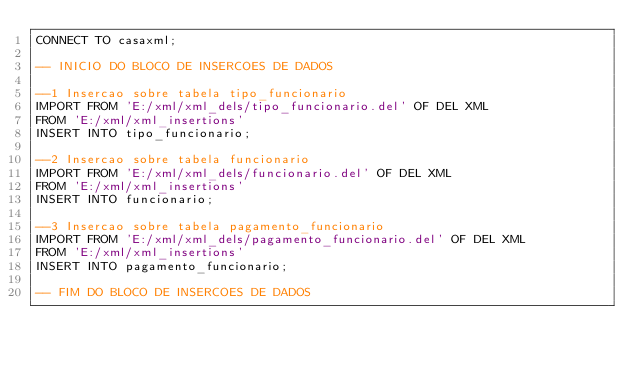<code> <loc_0><loc_0><loc_500><loc_500><_SQL_>CONNECT TO casaxml;

-- INICIO DO BLOCO DE INSERCOES DE DADOS

--1 Insercao sobre tabela tipo_funcionario
IMPORT FROM 'E:/xml/xml_dels/tipo_funcionario.del' OF DEL XML
FROM 'E:/xml/xml_insertions'
INSERT INTO tipo_funcionario;

--2 Insercao sobre tabela funcionario
IMPORT FROM 'E:/xml/xml_dels/funcionario.del' OF DEL XML
FROM 'E:/xml/xml_insertions'
INSERT INTO funcionario;

--3 Insercao sobre tabela pagamento_funcionario
IMPORT FROM 'E:/xml/xml_dels/pagamento_funcionario.del' OF DEL XML
FROM 'E:/xml/xml_insertions'
INSERT INTO pagamento_funcionario;

-- FIM DO BLOCO DE INSERCOES DE DADOS</code> 